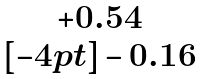Convert formula to latex. <formula><loc_0><loc_0><loc_500><loc_500>\begin{matrix} + 0 . 5 4 \\ [ - 4 p t ] - 0 . 1 6 \end{matrix}</formula> 